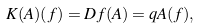<formula> <loc_0><loc_0><loc_500><loc_500>K ( A ) ( f ) = D f ( A ) = q A ( f ) ,</formula> 